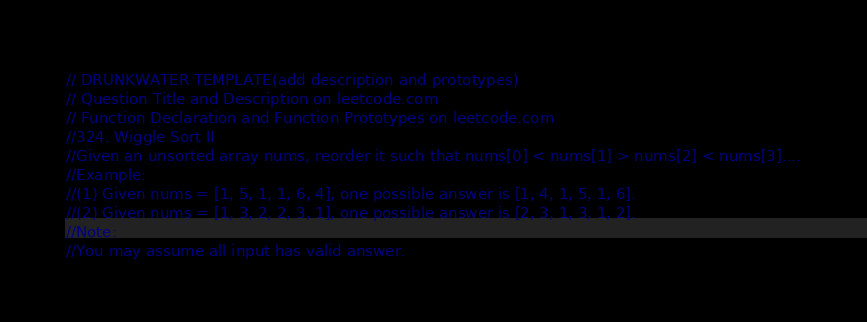<code> <loc_0><loc_0><loc_500><loc_500><_Scala_>// DRUNKWATER TEMPLATE(add description and prototypes)
// Question Title and Description on leetcode.com
// Function Declaration and Function Prototypes on leetcode.com
//324. Wiggle Sort II
//Given an unsorted array nums, reorder it such that nums[0] < nums[1] > nums[2] < nums[3]....
//Example:
//(1) Given nums = [1, 5, 1, 1, 6, 4], one possible answer is [1, 4, 1, 5, 1, 6].
//(2) Given nums = [1, 3, 2, 2, 3, 1], one possible answer is [2, 3, 1, 3, 1, 2].
//Note:
//You may assume all input has valid answer.</code> 